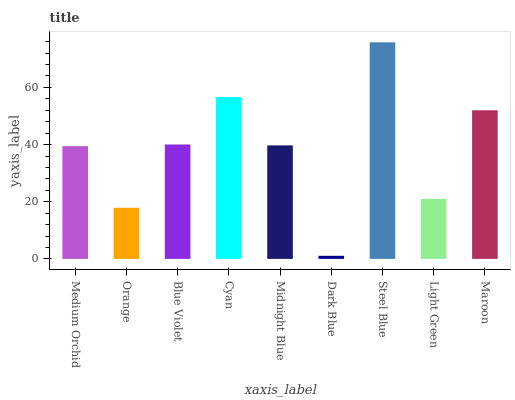Is Dark Blue the minimum?
Answer yes or no. Yes. Is Steel Blue the maximum?
Answer yes or no. Yes. Is Orange the minimum?
Answer yes or no. No. Is Orange the maximum?
Answer yes or no. No. Is Medium Orchid greater than Orange?
Answer yes or no. Yes. Is Orange less than Medium Orchid?
Answer yes or no. Yes. Is Orange greater than Medium Orchid?
Answer yes or no. No. Is Medium Orchid less than Orange?
Answer yes or no. No. Is Midnight Blue the high median?
Answer yes or no. Yes. Is Midnight Blue the low median?
Answer yes or no. Yes. Is Medium Orchid the high median?
Answer yes or no. No. Is Blue Violet the low median?
Answer yes or no. No. 